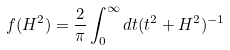Convert formula to latex. <formula><loc_0><loc_0><loc_500><loc_500>f ( H ^ { 2 } ) = \frac { 2 } { \pi } \int _ { 0 } ^ { \infty } d t ( t ^ { 2 } + H ^ { 2 } ) ^ { - 1 }</formula> 